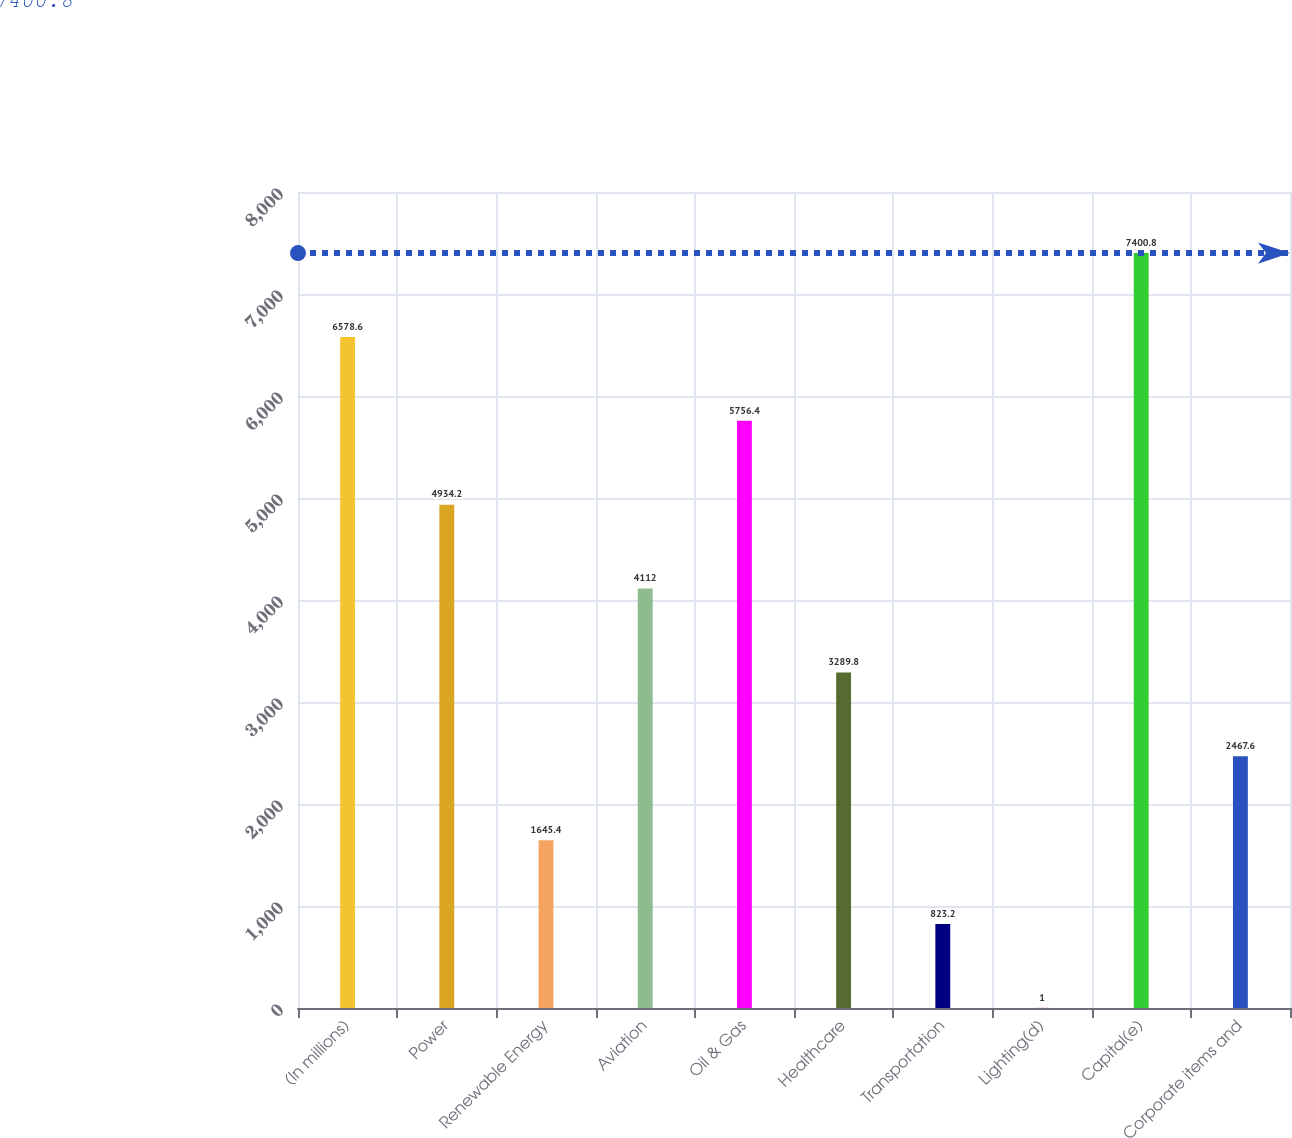Convert chart to OTSL. <chart><loc_0><loc_0><loc_500><loc_500><bar_chart><fcel>(In millions)<fcel>Power<fcel>Renewable Energy<fcel>Aviation<fcel>Oil & Gas<fcel>Healthcare<fcel>Transportation<fcel>Lighting(d)<fcel>Capital(e)<fcel>Corporate items and<nl><fcel>6578.6<fcel>4934.2<fcel>1645.4<fcel>4112<fcel>5756.4<fcel>3289.8<fcel>823.2<fcel>1<fcel>7400.8<fcel>2467.6<nl></chart> 